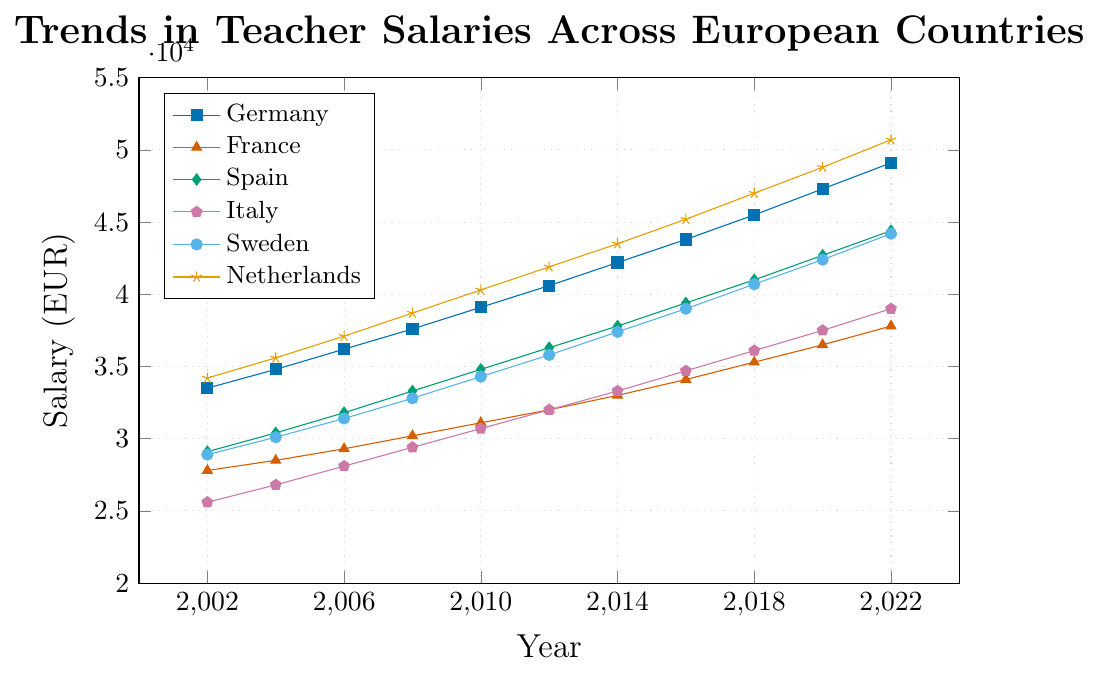Which country had the highest teacher salary in 2022? By looking at the graph, identify the country with the highest point on the y-axis in 2022. The Netherlands has the highest point marked in 2022.
Answer: The Netherlands Which country showed the highest growth in teacher salaries between 2002 and 2022? Calculate the difference in salaries between 2002 and 2022 for each country. The Netherlands' salary increased from 34,200 to 50,700, which is a growth of 16,500, the highest among all countries.
Answer: The Netherlands What was the average teacher salary in France across the entire period? Add all the salaries for France from 2002 to 2022 and divide by the number of years (11). The sum is (27800 + 28500 + 29300 + 30200 + 31100 + 32000 + 33000 + 34100 + 35300 + 36500 + 37800) = 365,300, the average is 365,300/11.
Answer: 33,209 By how much did Italy's teacher salaries increase from 2002 to 2010? Subtract the salary of Italy in 2002 from the salary in 2010. 30,700 (2010) - 25,600 (2002) = 6100.
Answer: 6,100 What is the difference in teacher salaries between Spain and Sweden in 2018? Subtract the salary of Sweden from the salary of Spain in 2018. 41,000 (Spain) - 40,700 (Sweden) = 300.
Answer: 300 Which country had the lowest teacher salary in 2006? Identify the country with the lowest point on the y-axis in 2006. Italy had the lowest salary at 28,100.
Answer: Italy During which period did Germany see the highest increase in teacher salaries? Compare the increase between consecutive periods for Germany. The highest increase was from 2002 (33,500) to 2004 (34,800) = 1,300.
Answer: 2002-2004 How many countries surpassed the 40,000 EUR mark by 2022? Identify the number of countries with salaries above 40,000 in 2022. Germany, Spain, Netherlands, and Sweden surpass the 40,000 EUR mark.
Answer: 4 What was the average annual increase in teacher salaries for France between 2010 and 2022? Subtract the salary of France in 2010 from the salary in 2022 and divide by the number of years (12). (37,800 - 31,100) = 6,700 / 12 = 558.33.
Answer: 558.33 Which country experienced the smallest overall salary growth from 2002 to 2022? Calculate and compare the salary growth for all countries between 2002 and 2022. France's salary increased from 27,800 to 37,800, which is an increase of 10,000, the smallest growth among all countries.
Answer: France 